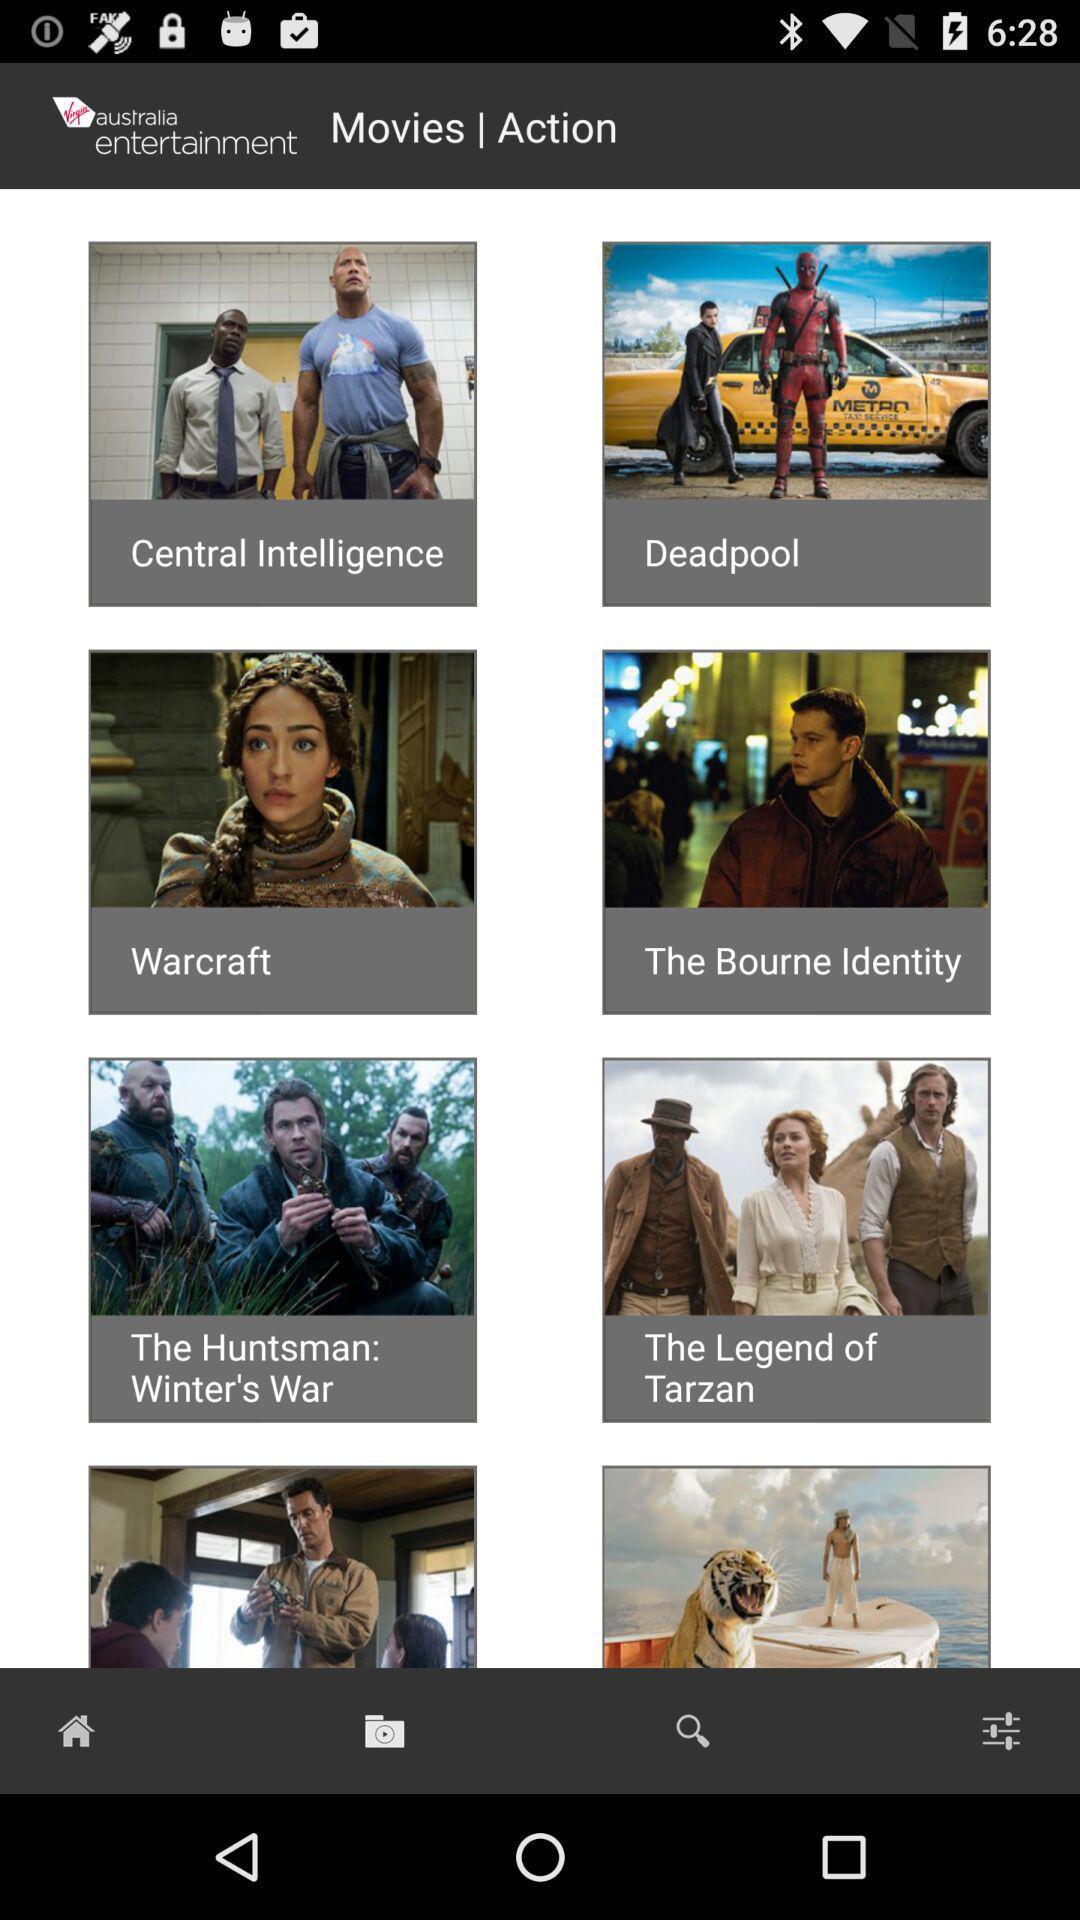Name some action movies? The names of some action movies are "Central Intelligence", "Deadpool", "Warcraft" and "The Bourne Identity". 